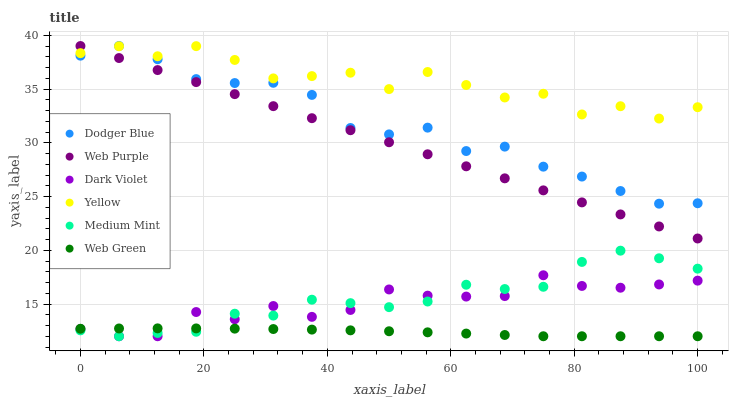Does Web Green have the minimum area under the curve?
Answer yes or no. Yes. Does Yellow have the maximum area under the curve?
Answer yes or no. Yes. Does Dark Violet have the minimum area under the curve?
Answer yes or no. No. Does Dark Violet have the maximum area under the curve?
Answer yes or no. No. Is Web Purple the smoothest?
Answer yes or no. Yes. Is Yellow the roughest?
Answer yes or no. Yes. Is Dark Violet the smoothest?
Answer yes or no. No. Is Dark Violet the roughest?
Answer yes or no. No. Does Medium Mint have the lowest value?
Answer yes or no. Yes. Does Web Purple have the lowest value?
Answer yes or no. No. Does Dodger Blue have the highest value?
Answer yes or no. Yes. Does Dark Violet have the highest value?
Answer yes or no. No. Is Dark Violet less than Yellow?
Answer yes or no. Yes. Is Web Purple greater than Medium Mint?
Answer yes or no. Yes. Does Dodger Blue intersect Web Purple?
Answer yes or no. Yes. Is Dodger Blue less than Web Purple?
Answer yes or no. No. Is Dodger Blue greater than Web Purple?
Answer yes or no. No. Does Dark Violet intersect Yellow?
Answer yes or no. No. 